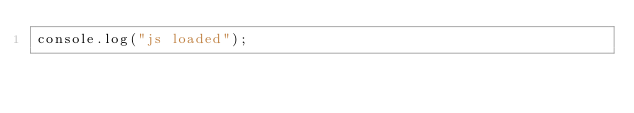<code> <loc_0><loc_0><loc_500><loc_500><_JavaScript_>console.log("js loaded");
</code> 